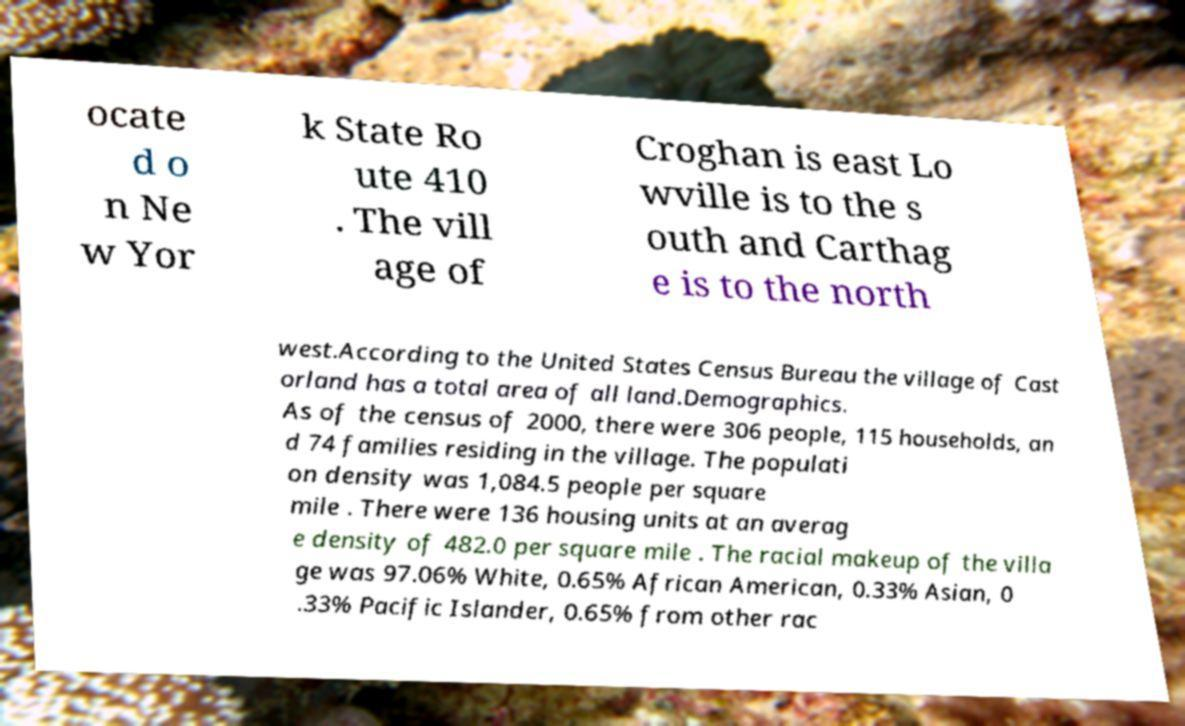There's text embedded in this image that I need extracted. Can you transcribe it verbatim? ocate d o n Ne w Yor k State Ro ute 410 . The vill age of Croghan is east Lo wville is to the s outh and Carthag e is to the north west.According to the United States Census Bureau the village of Cast orland has a total area of all land.Demographics. As of the census of 2000, there were 306 people, 115 households, an d 74 families residing in the village. The populati on density was 1,084.5 people per square mile . There were 136 housing units at an averag e density of 482.0 per square mile . The racial makeup of the villa ge was 97.06% White, 0.65% African American, 0.33% Asian, 0 .33% Pacific Islander, 0.65% from other rac 